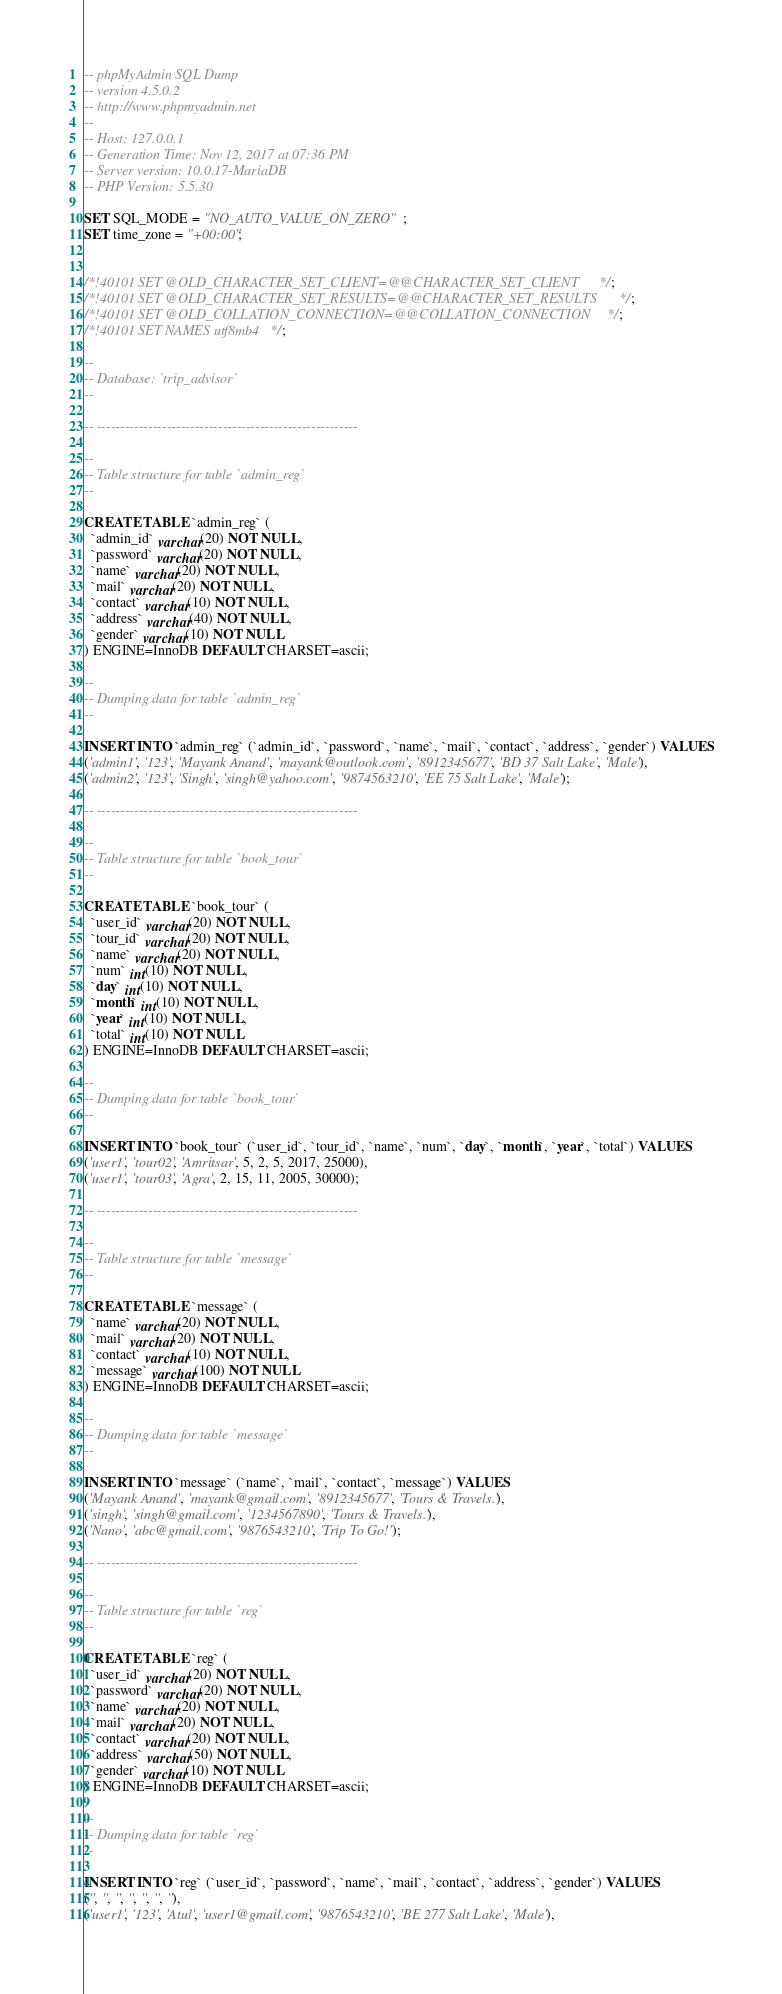Convert code to text. <code><loc_0><loc_0><loc_500><loc_500><_SQL_>-- phpMyAdmin SQL Dump
-- version 4.5.0.2
-- http://www.phpmyadmin.net
--
-- Host: 127.0.0.1
-- Generation Time: Nov 12, 2017 at 07:36 PM
-- Server version: 10.0.17-MariaDB
-- PHP Version: 5.5.30

SET SQL_MODE = "NO_AUTO_VALUE_ON_ZERO";
SET time_zone = "+00:00";


/*!40101 SET @OLD_CHARACTER_SET_CLIENT=@@CHARACTER_SET_CLIENT */;
/*!40101 SET @OLD_CHARACTER_SET_RESULTS=@@CHARACTER_SET_RESULTS */;
/*!40101 SET @OLD_COLLATION_CONNECTION=@@COLLATION_CONNECTION */;
/*!40101 SET NAMES utf8mb4 */;

--
-- Database: `trip_advisor`
--

-- --------------------------------------------------------

--
-- Table structure for table `admin_reg`
--

CREATE TABLE `admin_reg` (
  `admin_id` varchar(20) NOT NULL,
  `password` varchar(20) NOT NULL,
  `name` varchar(20) NOT NULL,
  `mail` varchar(20) NOT NULL,
  `contact` varchar(10) NOT NULL,
  `address` varchar(40) NOT NULL,
  `gender` varchar(10) NOT NULL
) ENGINE=InnoDB DEFAULT CHARSET=ascii;

--
-- Dumping data for table `admin_reg`
--

INSERT INTO `admin_reg` (`admin_id`, `password`, `name`, `mail`, `contact`, `address`, `gender`) VALUES
('admin1', '123', 'Mayank Anand', 'mayank@outlook.com', '8912345677', 'BD 37 Salt Lake', 'Male'),
('admin2', '123', 'Singh', 'singh@yahoo.com', '9874563210', 'EE 75 Salt Lake', 'Male');

-- --------------------------------------------------------

--
-- Table structure for table `book_tour`
--

CREATE TABLE `book_tour` (
  `user_id` varchar(20) NOT NULL,
  `tour_id` varchar(20) NOT NULL,
  `name` varchar(20) NOT NULL,
  `num` int(10) NOT NULL,
  `day` int(10) NOT NULL,
  `month` int(10) NOT NULL,
  `year` int(10) NOT NULL,
  `total` int(10) NOT NULL
) ENGINE=InnoDB DEFAULT CHARSET=ascii;

--
-- Dumping data for table `book_tour`
--

INSERT INTO `book_tour` (`user_id`, `tour_id`, `name`, `num`, `day`, `month`, `year`, `total`) VALUES
('user1', 'tour02', 'Amritsar', 5, 2, 5, 2017, 25000),
('user1', 'tour03', 'Agra', 2, 15, 11, 2005, 30000);

-- --------------------------------------------------------

--
-- Table structure for table `message`
--

CREATE TABLE `message` (
  `name` varchar(20) NOT NULL,
  `mail` varchar(20) NOT NULL,
  `contact` varchar(10) NOT NULL,
  `message` varchar(100) NOT NULL
) ENGINE=InnoDB DEFAULT CHARSET=ascii;

--
-- Dumping data for table `message`
--

INSERT INTO `message` (`name`, `mail`, `contact`, `message`) VALUES
('Mayank Anand', 'mayank@gmail.com', '8912345677', 'Tours & Travels.'),
('singh', 'singh@gmail.com', '1234567890', 'Tours & Travels.'),
('Nano', 'abc@gmail.com', '9876543210', 'Trip To Go!');

-- --------------------------------------------------------

--
-- Table structure for table `reg`
--

CREATE TABLE `reg` (
  `user_id` varchar(20) NOT NULL,
  `password` varchar(20) NOT NULL,
  `name` varchar(20) NOT NULL,
  `mail` varchar(20) NOT NULL,
  `contact` varchar(20) NOT NULL,
  `address` varchar(50) NOT NULL,
  `gender` varchar(10) NOT NULL
) ENGINE=InnoDB DEFAULT CHARSET=ascii;

--
-- Dumping data for table `reg`
--

INSERT INTO `reg` (`user_id`, `password`, `name`, `mail`, `contact`, `address`, `gender`) VALUES
('', '', '', '', '', '', ''),
('user1', '123', 'Atul', 'user1@gmail.com', '9876543210', 'BE 277 Salt Lake', 'Male'),</code> 